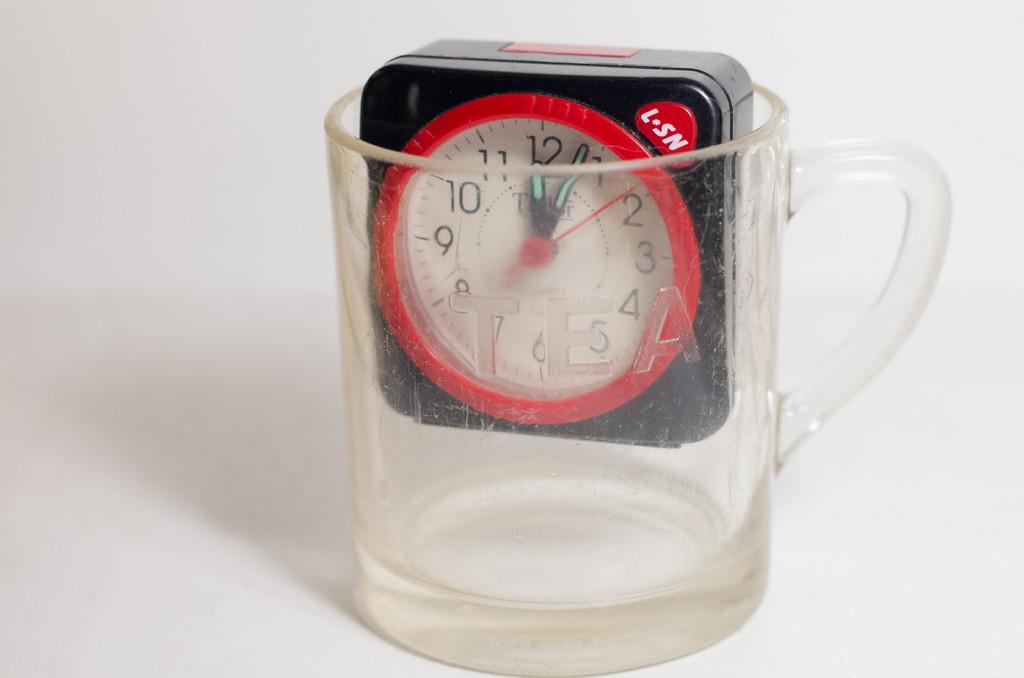What time does the clock say it is?
Offer a terse response. 12:04. What is written in the upper right hand corner?
Your answer should be compact. L sn. 